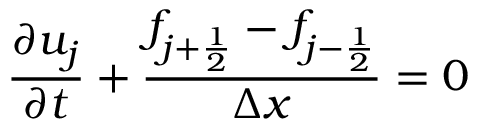<formula> <loc_0><loc_0><loc_500><loc_500>\frac { \partial u _ { j } } { \partial t } + \frac { f _ { j + \frac { 1 } { 2 } } - f _ { j - \frac { 1 } { 2 } } } { \Delta x } = 0</formula> 